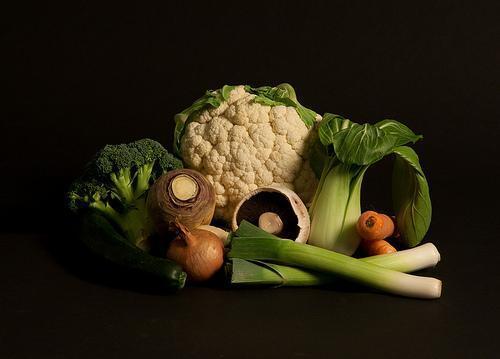How many carrots are visible?
Give a very brief answer. 2. 